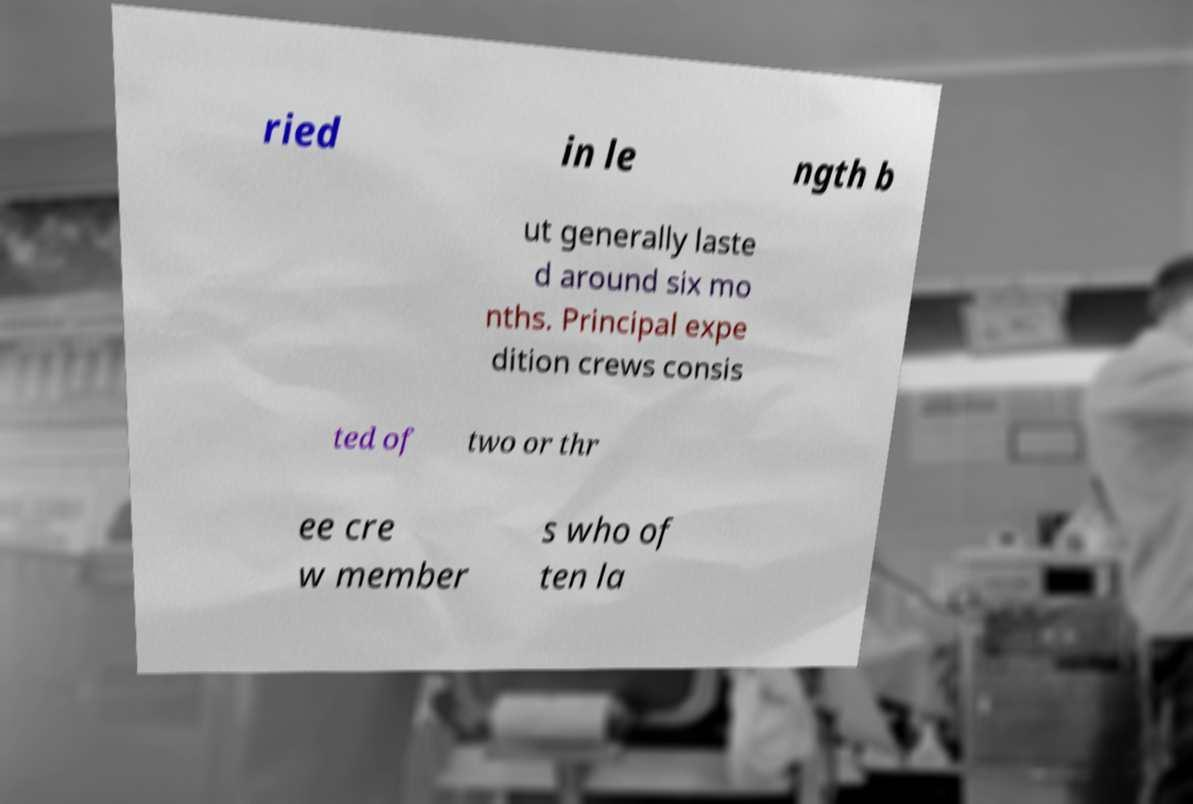For documentation purposes, I need the text within this image transcribed. Could you provide that? ried in le ngth b ut generally laste d around six mo nths. Principal expe dition crews consis ted of two or thr ee cre w member s who of ten la 